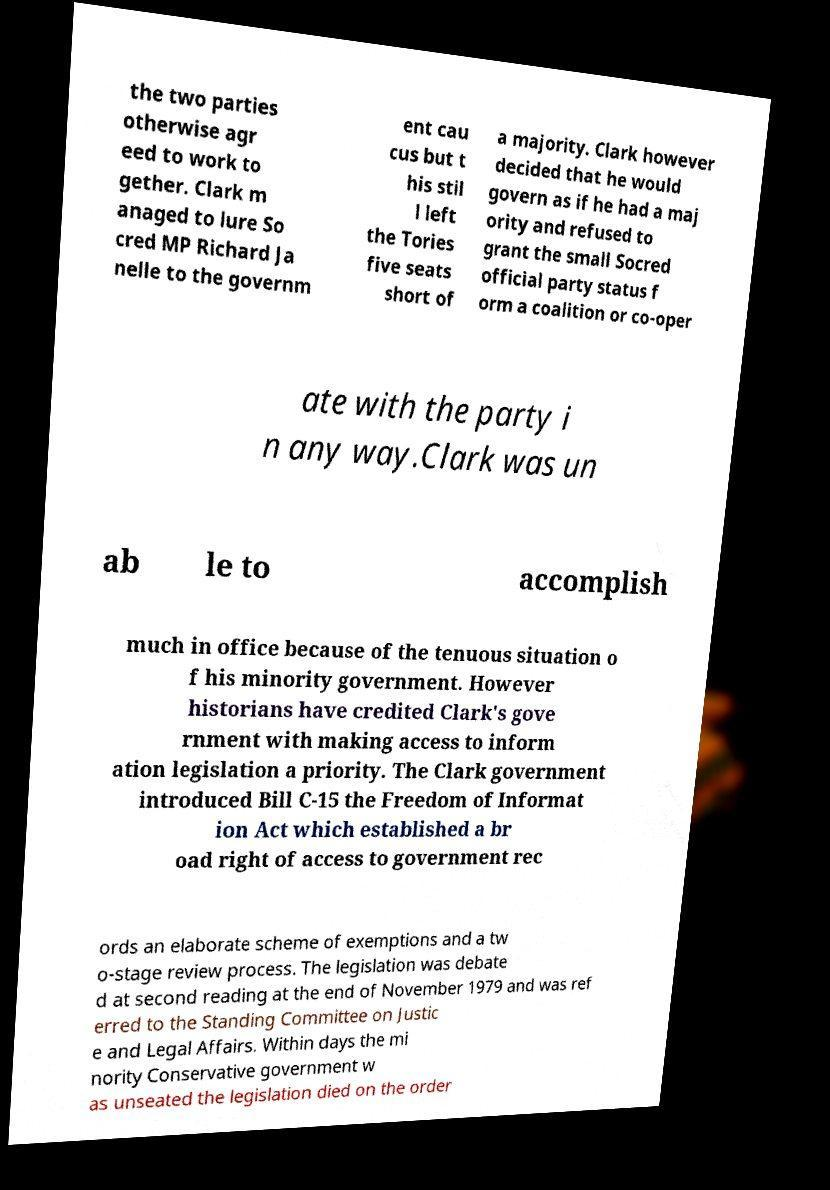What messages or text are displayed in this image? I need them in a readable, typed format. the two parties otherwise agr eed to work to gether. Clark m anaged to lure So cred MP Richard Ja nelle to the governm ent cau cus but t his stil l left the Tories five seats short of a majority. Clark however decided that he would govern as if he had a maj ority and refused to grant the small Socred official party status f orm a coalition or co-oper ate with the party i n any way.Clark was un ab le to accomplish much in office because of the tenuous situation o f his minority government. However historians have credited Clark's gove rnment with making access to inform ation legislation a priority. The Clark government introduced Bill C-15 the Freedom of Informat ion Act which established a br oad right of access to government rec ords an elaborate scheme of exemptions and a tw o-stage review process. The legislation was debate d at second reading at the end of November 1979 and was ref erred to the Standing Committee on Justic e and Legal Affairs. Within days the mi nority Conservative government w as unseated the legislation died on the order 